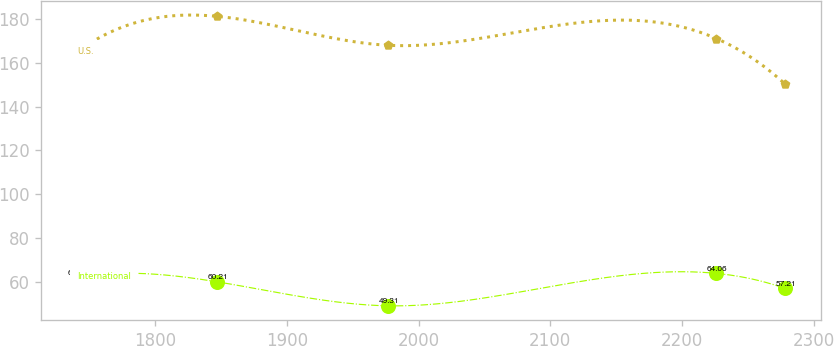<chart> <loc_0><loc_0><loc_500><loc_500><line_chart><ecel><fcel>U.S.<fcel>International<nl><fcel>1740.49<fcel>164.78<fcel>62.36<nl><fcel>1847.14<fcel>181.03<fcel>60.21<nl><fcel>1976.94<fcel>167.86<fcel>49.31<nl><fcel>2226.14<fcel>170.94<fcel>64.06<nl><fcel>2278.37<fcel>150.21<fcel>57.21<nl></chart> 